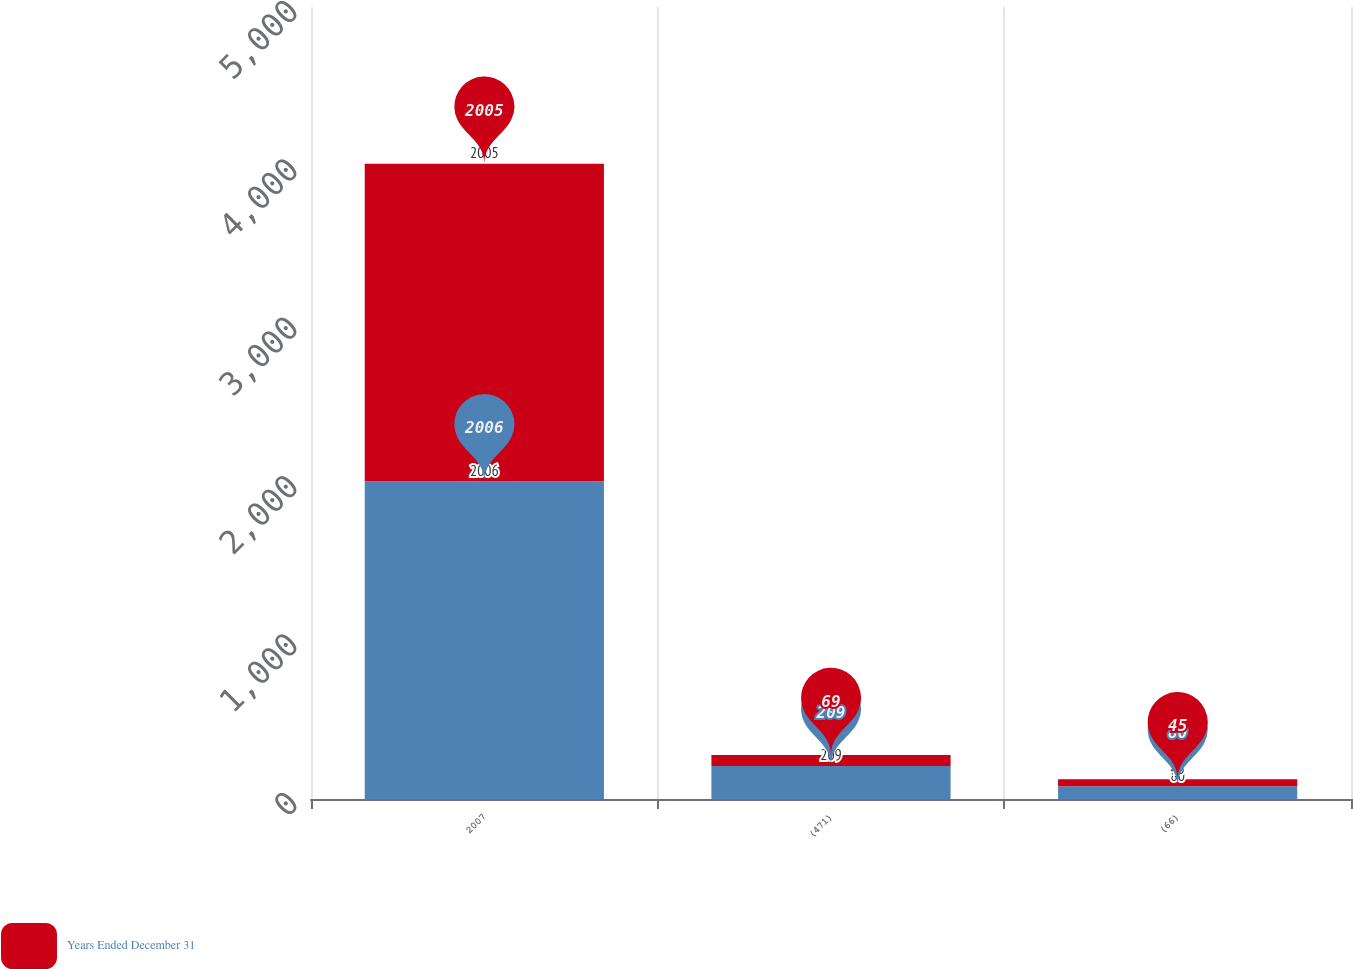<chart> <loc_0><loc_0><loc_500><loc_500><stacked_bar_chart><ecel><fcel>2007<fcel>(471)<fcel>(66)<nl><fcel>nan<fcel>2006<fcel>209<fcel>80<nl><fcel>Years Ended December 31<fcel>2005<fcel>69<fcel>45<nl></chart> 